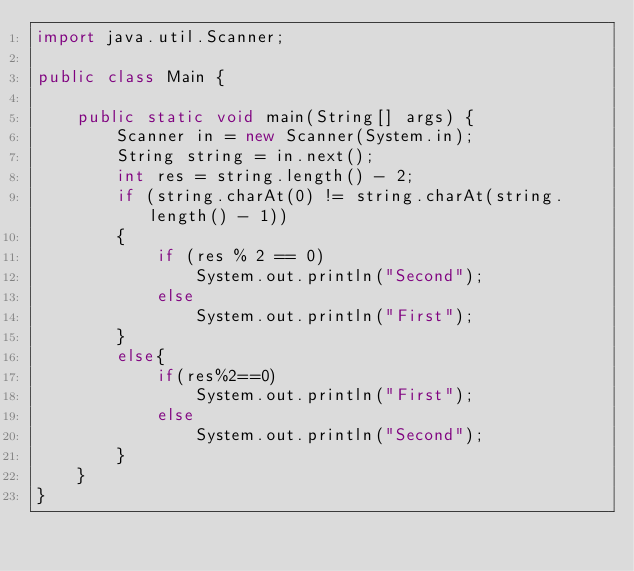<code> <loc_0><loc_0><loc_500><loc_500><_Java_>import java.util.Scanner;

public class Main {

    public static void main(String[] args) {
        Scanner in = new Scanner(System.in);
        String string = in.next();
        int res = string.length() - 2;
        if (string.charAt(0) != string.charAt(string.length() - 1))
        {
            if (res % 2 == 0)
                System.out.println("Second");
            else
                System.out.println("First");
        }
        else{
            if(res%2==0)
                System.out.println("First");
            else
                System.out.println("Second");
        }
    }
}
</code> 